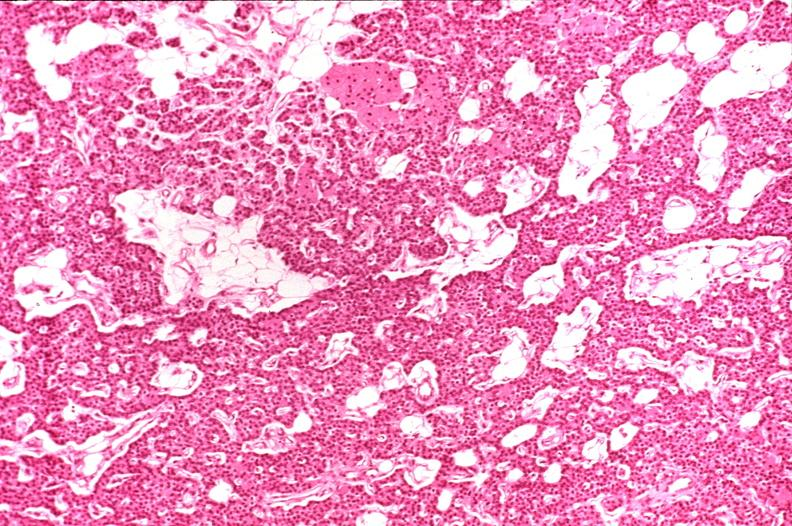s endocrine present?
Answer the question using a single word or phrase. Yes 